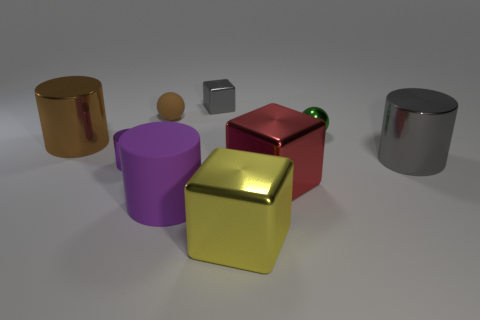What number of objects are either large brown things or tiny metallic things left of the large red metal object? Upon reviewing the image, there are 2 objects that meet the criteria: one large brown cylindrical object and one tiny metallic cube. It's intriguing to see such varied shapes and colors, and how they relate to each other in space. 